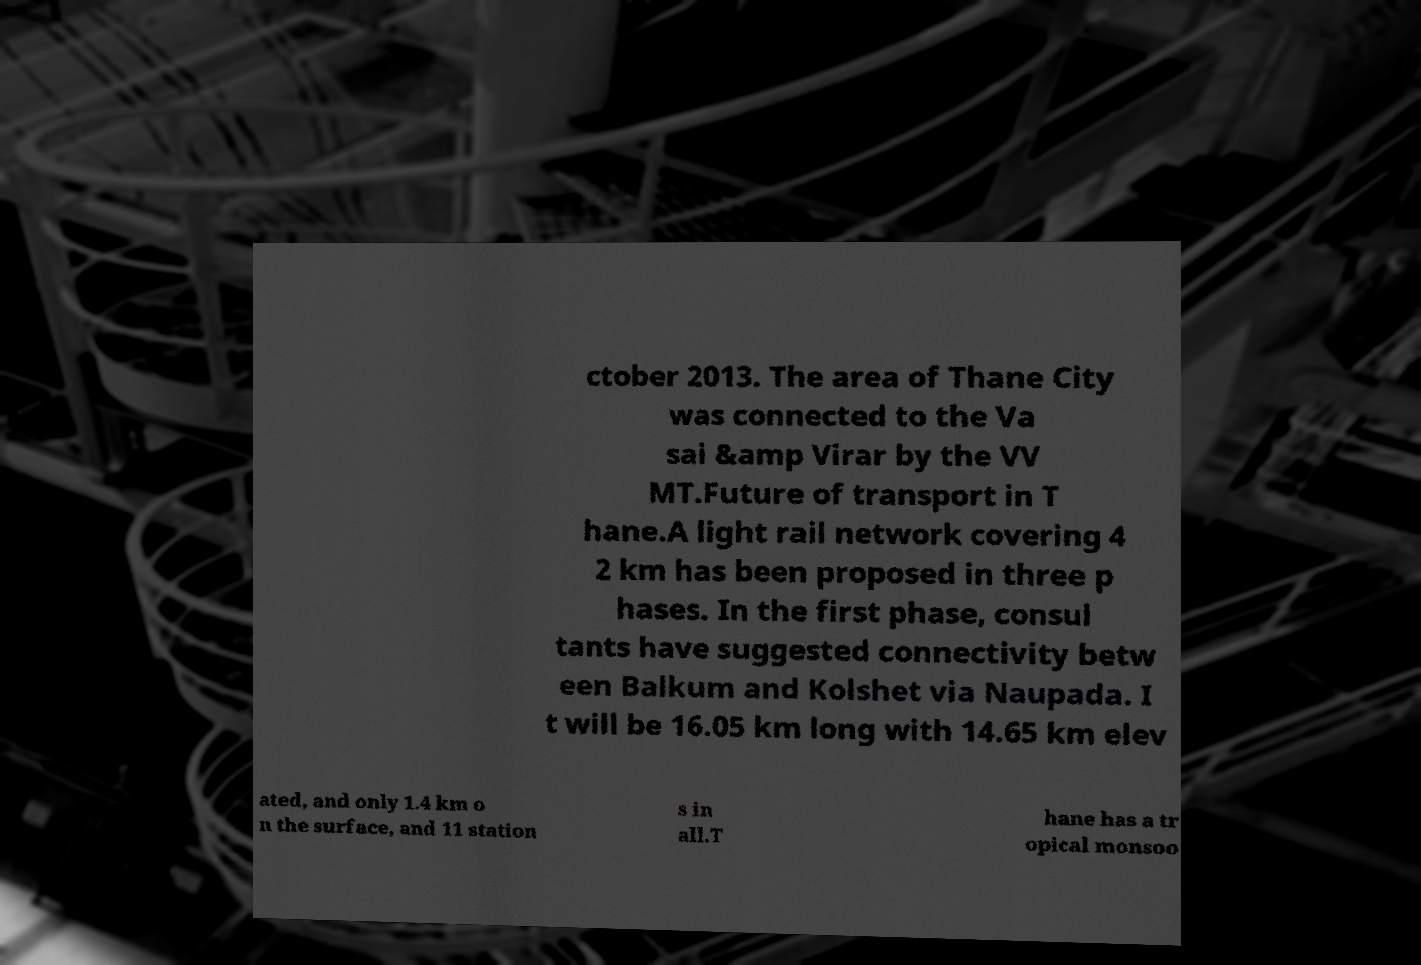I need the written content from this picture converted into text. Can you do that? ctober 2013. The area of Thane City was connected to the Va sai &amp Virar by the VV MT.Future of transport in T hane.A light rail network covering 4 2 km has been proposed in three p hases. In the first phase, consul tants have suggested connectivity betw een Balkum and Kolshet via Naupada. I t will be 16.05 km long with 14.65 km elev ated, and only 1.4 km o n the surface, and 11 station s in all.T hane has a tr opical monsoo 